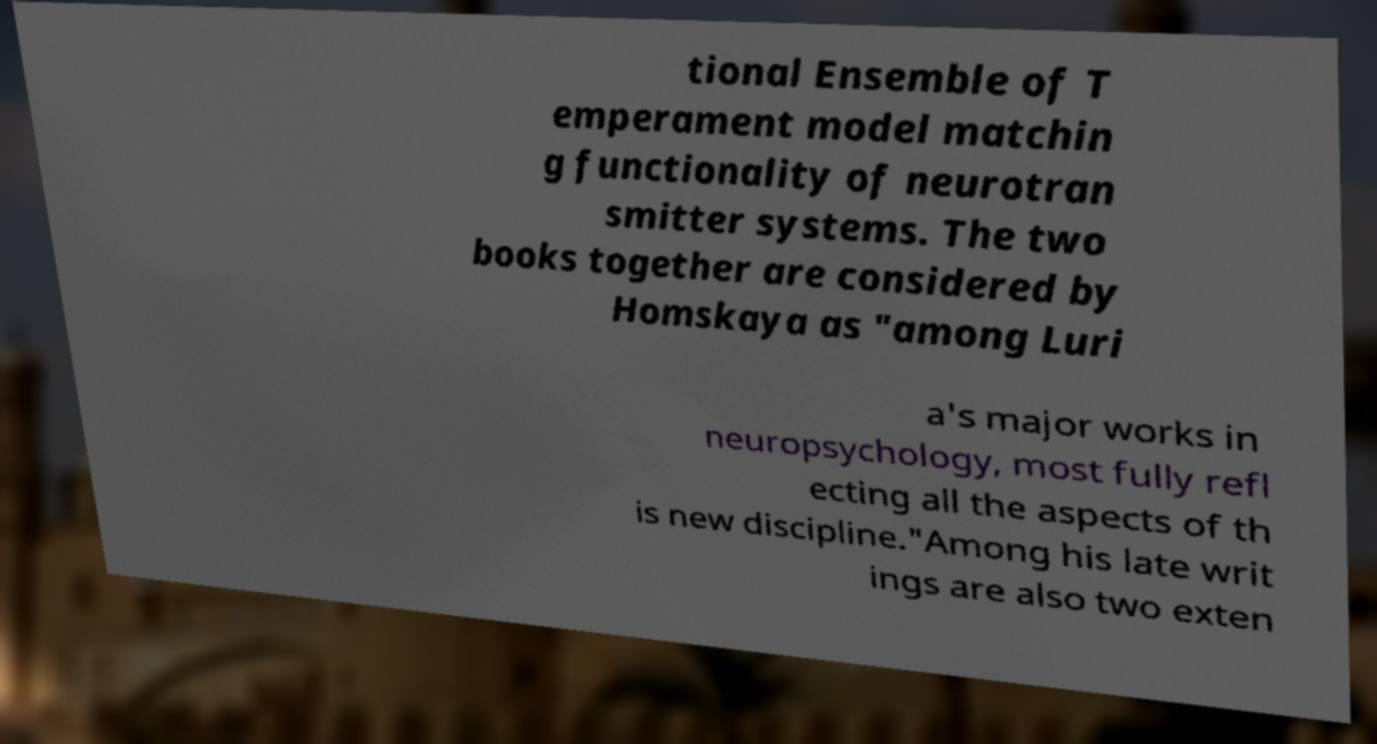I need the written content from this picture converted into text. Can you do that? tional Ensemble of T emperament model matchin g functionality of neurotran smitter systems. The two books together are considered by Homskaya as "among Luri a's major works in neuropsychology, most fully refl ecting all the aspects of th is new discipline."Among his late writ ings are also two exten 